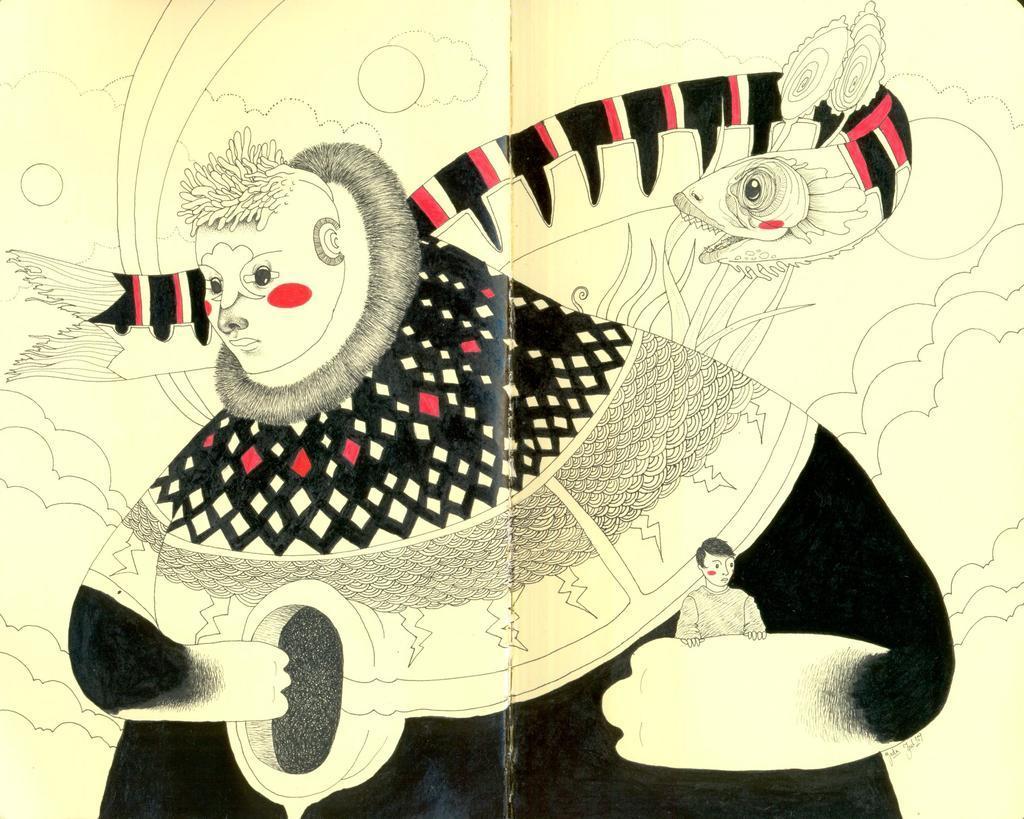Describe this image in one or two sentences. In this image, It looks like a drawing on the paper. Here is a person. I think this is a kind of a fish. 